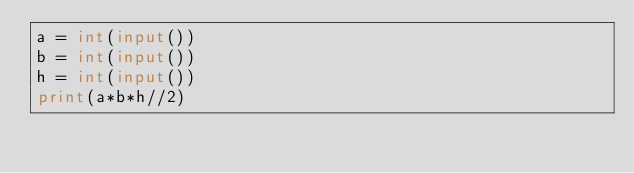<code> <loc_0><loc_0><loc_500><loc_500><_Python_>a = int(input())
b = int(input())
h = int(input())
print(a*b*h//2)</code> 